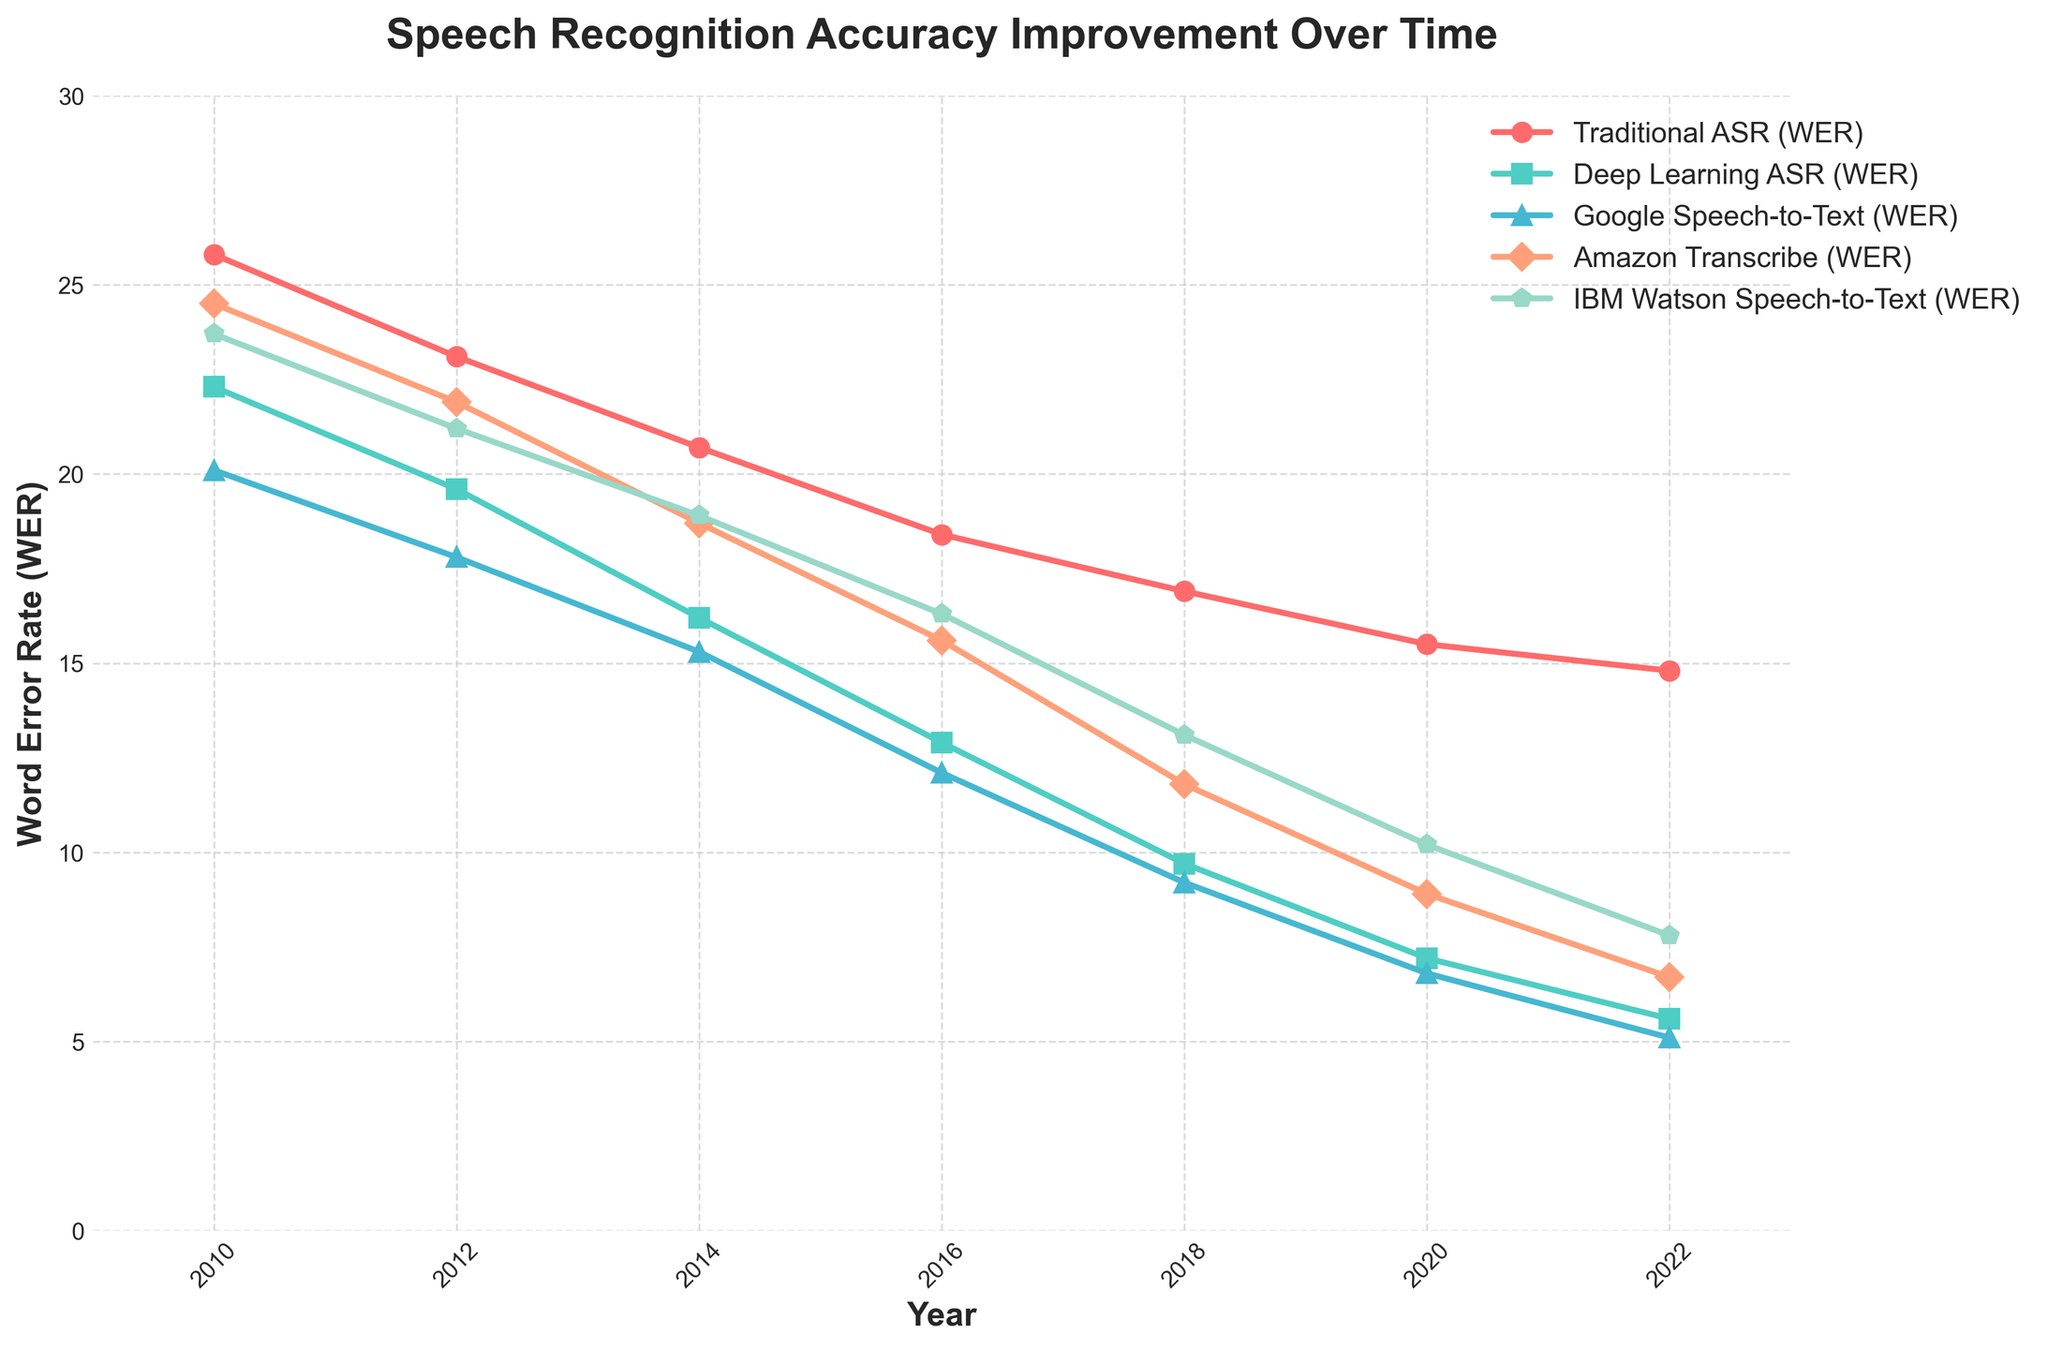Which year shows the lowest Word Error Rate (WER) for Deep Learning ASR? To determine the year with the lowest WER for Deep Learning ASR, we check the WER values across different years for the Deep Learning ASR line and find the year with the smallest value, which is 5.6 in 2022.
Answer: 2022 Compare the WER between Traditional ASR and Google Speech-to-Text in 2016. Which one performed better? By examining the figure, we compare the WER values for 2016: Traditional ASR has a WER of 18.4, and Google Speech-to-Text has a WER of 12.1. Google Speech-to-Text has a lower WER, indicating better performance.
Answer: Google Speech-to-Text What is the range of the WER values for Amazon Transcribe from 2010 to 2022? The range is calculated by finding the difference between the highest and lowest WER values for Amazon Transcribe. The highest value is 24.5 in 2010, and the lowest is 6.7 in 2022. The range is 24.5 - 6.7 = 17.8.
Answer: 17.8 Between 2010 and 2022, which speech recognition system has shown the most significant improvement in WER? To determine the system with the most significant improvement, we calculate the difference between the WER values in 2010 and 2022 for each system. The system with the largest reduction is Deep Learning ASR, with an improvement of 22.3 - 5.6 = 16.7.
Answer: Deep Learning ASR By how much did the WER of IBM Watson Speech-to-Text decrease from 2010 to 2018? The decrease in WER is calculated by subtracting the WER value in 2018 from that in 2010 for IBM Watson Speech-to-Text. In 2010, the WER was 23.7, and in 2018 it was 13.1. Thus, the decrease is 23.7 - 13.1 = 10.6.
Answer: 10.6 What is the average WER for Traditional ASR over the years shown? The average WER for Traditional ASR is calculated by summing all WER values from 2010 to 2022 and then dividing by the number of years. The values are 25.8, 23.1, 20.7, 18.4, 16.9, 15.5, and 14.8. The sum is 135.2, and there are 7 values, so the average is 135.2 / 7 ≈ 19.3.
Answer: 19.3 Which company had the lowest WER in 2020 among Amazon, Google, and IBM? In 2020, we compare the WERs for Amazon Transcribe (8.9), Google Speech-to-Text (6.8), and IBM Watson Speech-to-Text (10.2). Google Speech-to-Text has the lowest WER, which indicates the best performance.
Answer: Google Speech-to-Text In which year did Deep Learning ASR first achieve a WER below 10? By inspecting the line corresponding to Deep Learning ASR, we find that the first year with a WER below 10 is 2018 when the WER was 9.7.
Answer: 2018 